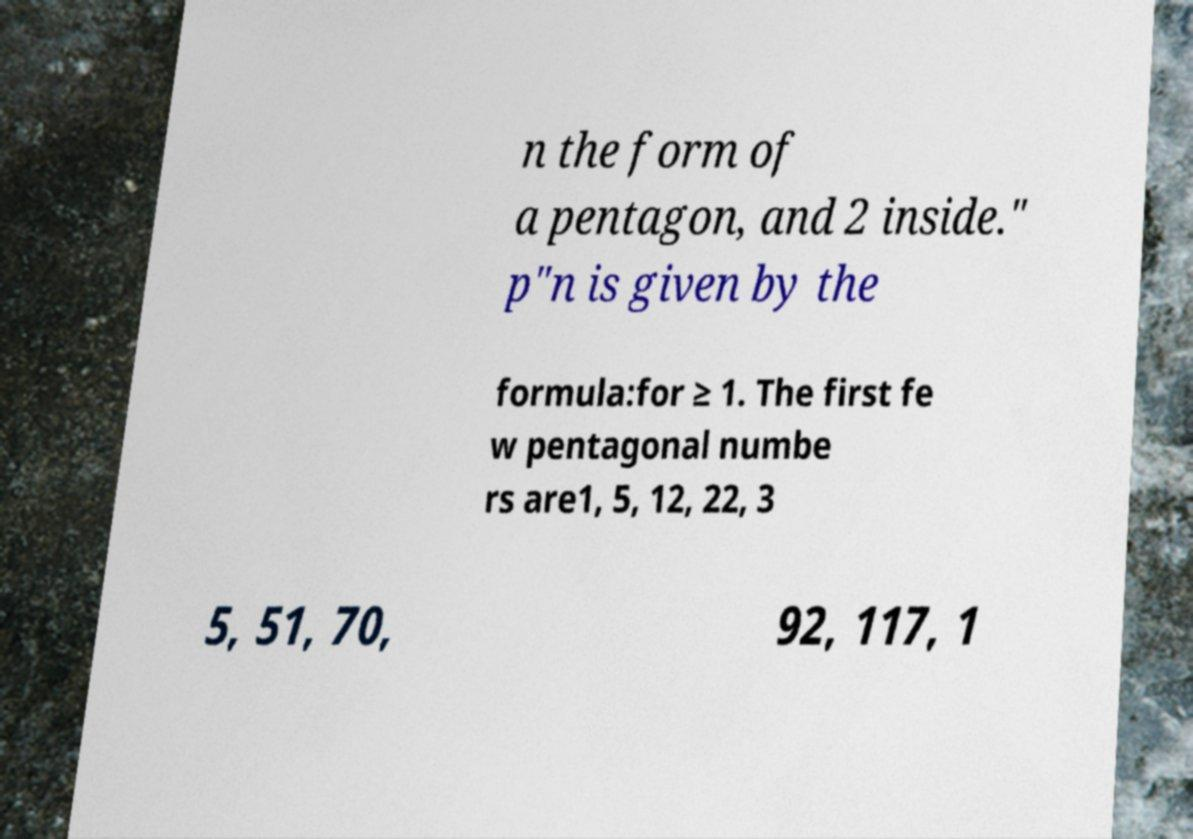Could you assist in decoding the text presented in this image and type it out clearly? n the form of a pentagon, and 2 inside." p"n is given by the formula:for ≥ 1. The first fe w pentagonal numbe rs are1, 5, 12, 22, 3 5, 51, 70, 92, 117, 1 